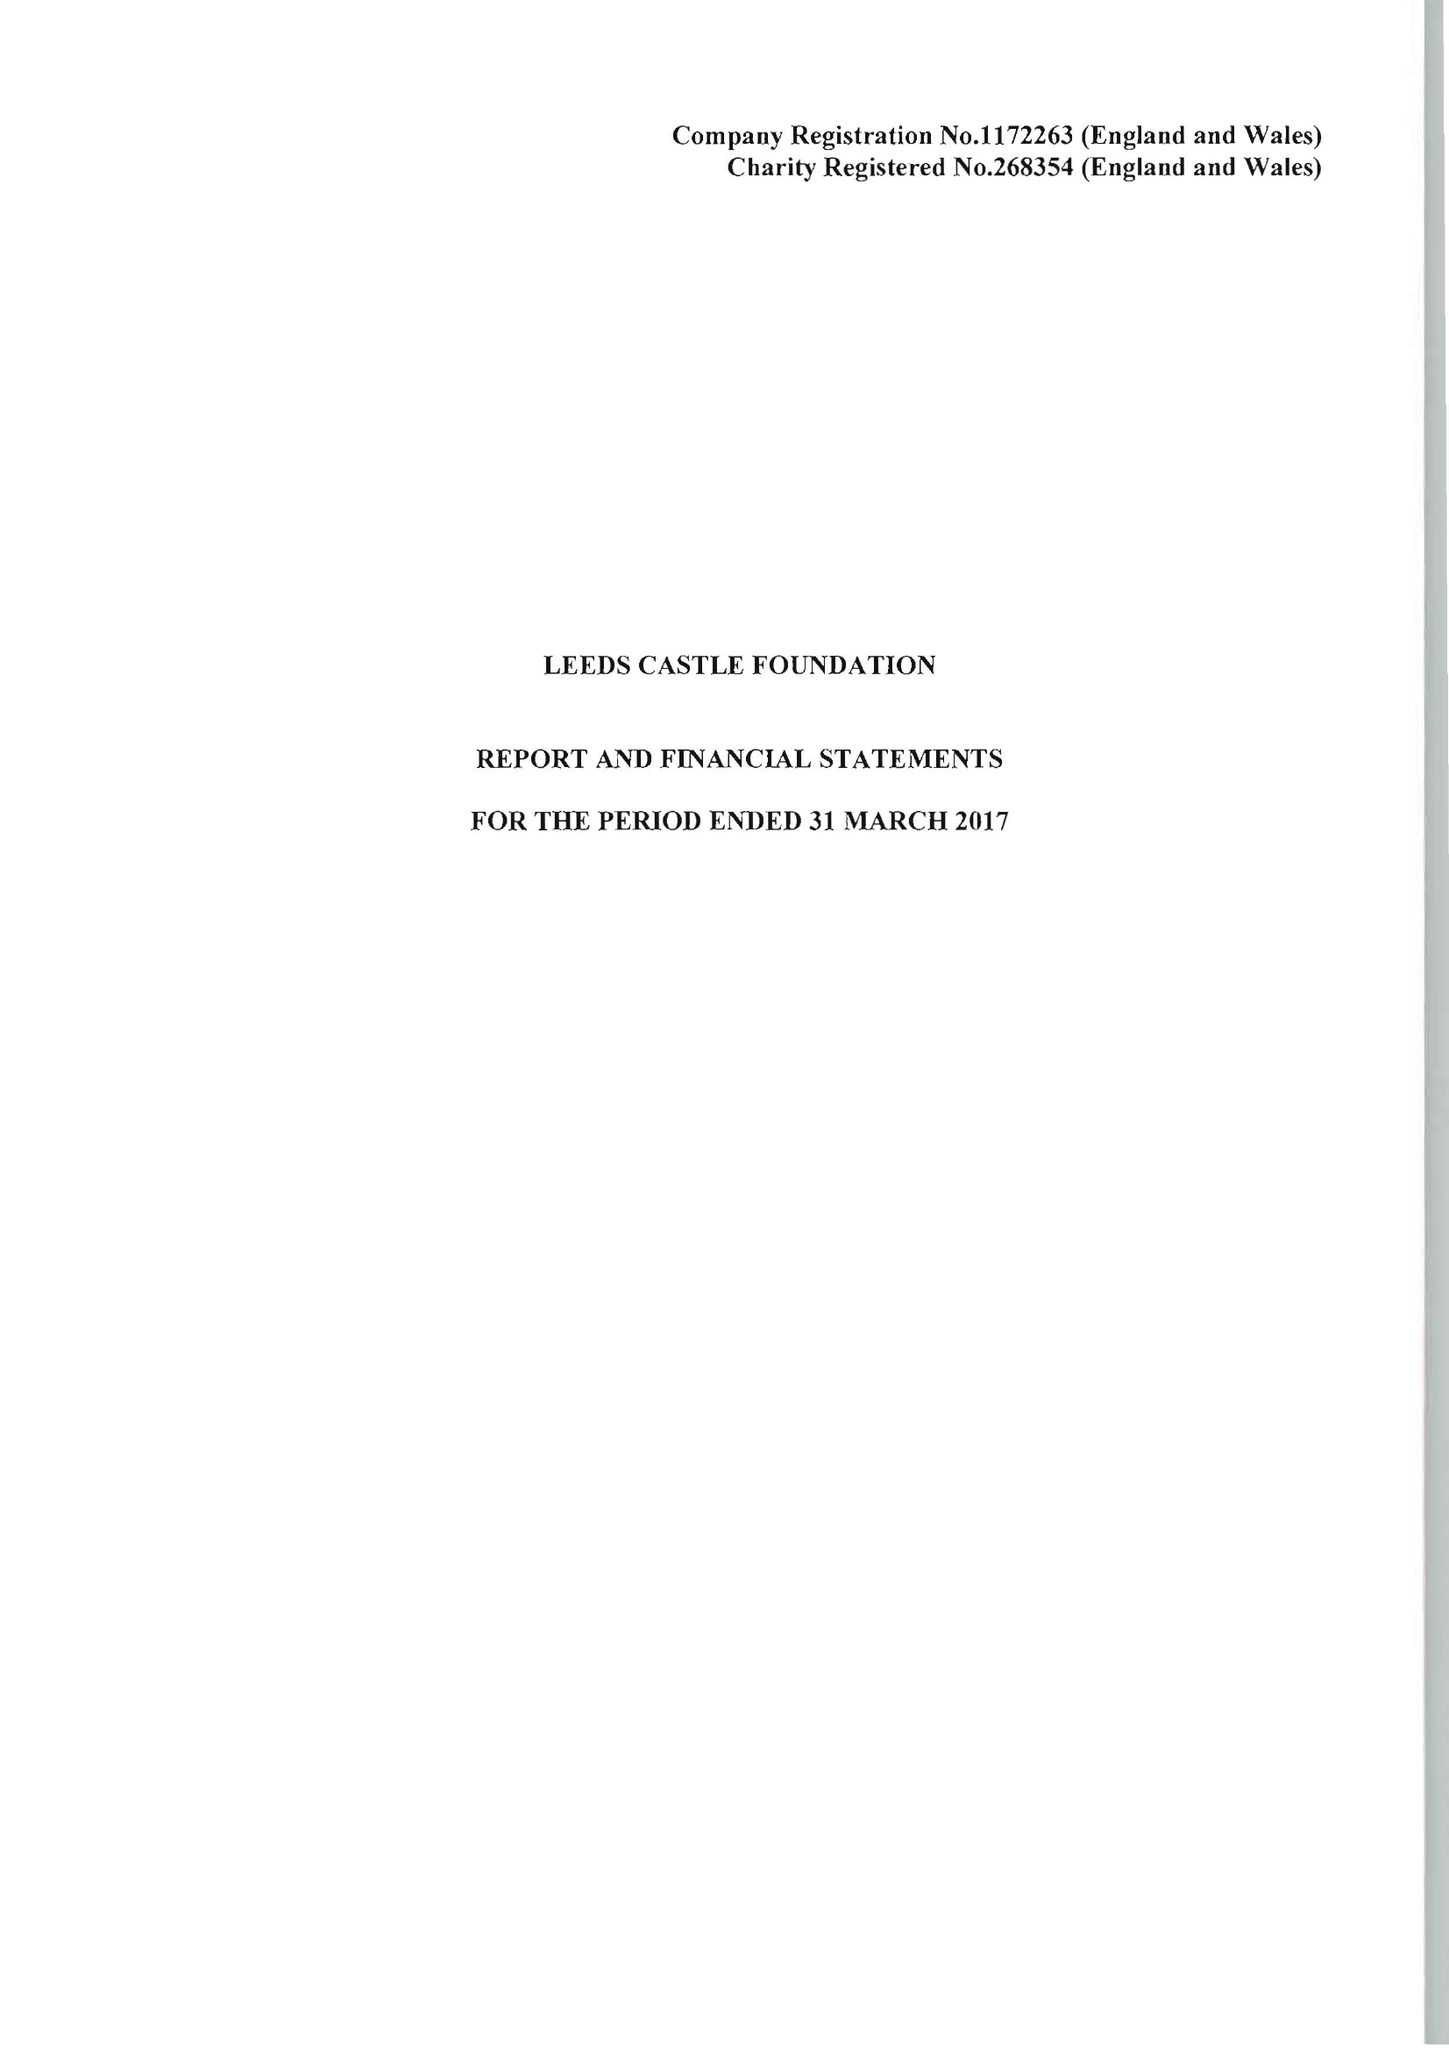What is the value for the report_date?
Answer the question using a single word or phrase. 2017-03-31 